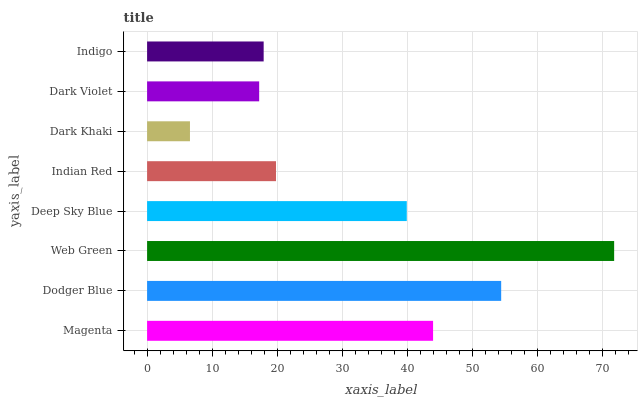Is Dark Khaki the minimum?
Answer yes or no. Yes. Is Web Green the maximum?
Answer yes or no. Yes. Is Dodger Blue the minimum?
Answer yes or no. No. Is Dodger Blue the maximum?
Answer yes or no. No. Is Dodger Blue greater than Magenta?
Answer yes or no. Yes. Is Magenta less than Dodger Blue?
Answer yes or no. Yes. Is Magenta greater than Dodger Blue?
Answer yes or no. No. Is Dodger Blue less than Magenta?
Answer yes or no. No. Is Deep Sky Blue the high median?
Answer yes or no. Yes. Is Indian Red the low median?
Answer yes or no. Yes. Is Magenta the high median?
Answer yes or no. No. Is Dark Khaki the low median?
Answer yes or no. No. 